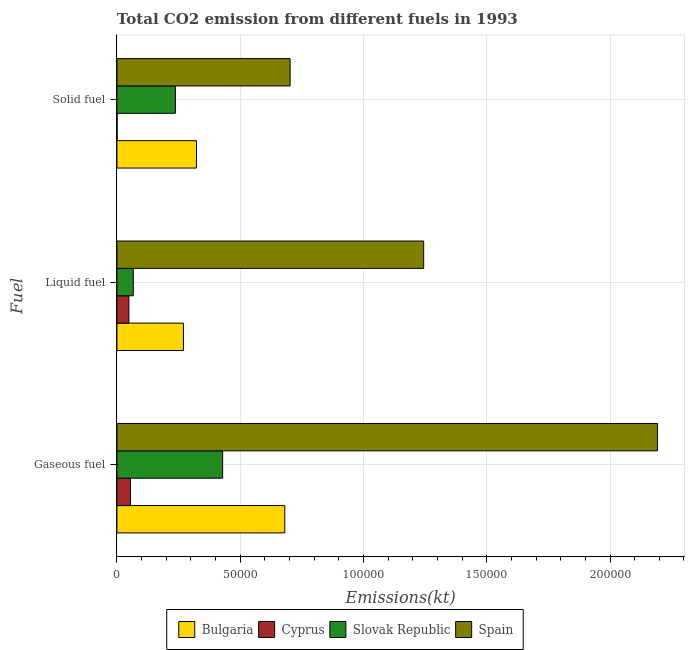Are the number of bars per tick equal to the number of legend labels?
Your response must be concise. Yes. Are the number of bars on each tick of the Y-axis equal?
Your response must be concise. Yes. How many bars are there on the 3rd tick from the top?
Your answer should be very brief. 4. How many bars are there on the 1st tick from the bottom?
Make the answer very short. 4. What is the label of the 3rd group of bars from the top?
Keep it short and to the point. Gaseous fuel. What is the amount of co2 emissions from solid fuel in Cyprus?
Your answer should be very brief. 80.67. Across all countries, what is the maximum amount of co2 emissions from solid fuel?
Ensure brevity in your answer.  7.02e+04. Across all countries, what is the minimum amount of co2 emissions from liquid fuel?
Keep it short and to the point. 4858.77. In which country was the amount of co2 emissions from solid fuel maximum?
Give a very brief answer. Spain. In which country was the amount of co2 emissions from solid fuel minimum?
Provide a short and direct response. Cyprus. What is the total amount of co2 emissions from liquid fuel in the graph?
Offer a terse response. 1.63e+05. What is the difference between the amount of co2 emissions from liquid fuel in Bulgaria and that in Cyprus?
Give a very brief answer. 2.21e+04. What is the difference between the amount of co2 emissions from gaseous fuel in Spain and the amount of co2 emissions from liquid fuel in Cyprus?
Your answer should be very brief. 2.14e+05. What is the average amount of co2 emissions from solid fuel per country?
Provide a succinct answer. 3.16e+04. What is the difference between the amount of co2 emissions from liquid fuel and amount of co2 emissions from gaseous fuel in Cyprus?
Keep it short and to the point. -627.06. In how many countries, is the amount of co2 emissions from gaseous fuel greater than 80000 kt?
Keep it short and to the point. 1. What is the ratio of the amount of co2 emissions from gaseous fuel in Bulgaria to that in Cyprus?
Make the answer very short. 12.41. Is the amount of co2 emissions from liquid fuel in Spain less than that in Slovak Republic?
Offer a terse response. No. Is the difference between the amount of co2 emissions from gaseous fuel in Cyprus and Slovak Republic greater than the difference between the amount of co2 emissions from solid fuel in Cyprus and Slovak Republic?
Offer a very short reply. No. What is the difference between the highest and the second highest amount of co2 emissions from gaseous fuel?
Provide a succinct answer. 1.51e+05. What is the difference between the highest and the lowest amount of co2 emissions from solid fuel?
Your answer should be compact. 7.02e+04. In how many countries, is the amount of co2 emissions from gaseous fuel greater than the average amount of co2 emissions from gaseous fuel taken over all countries?
Keep it short and to the point. 1. What does the 3rd bar from the top in Solid fuel represents?
Offer a very short reply. Cyprus. What does the 4th bar from the bottom in Solid fuel represents?
Your response must be concise. Spain. Is it the case that in every country, the sum of the amount of co2 emissions from gaseous fuel and amount of co2 emissions from liquid fuel is greater than the amount of co2 emissions from solid fuel?
Keep it short and to the point. Yes. How many countries are there in the graph?
Provide a short and direct response. 4. Are the values on the major ticks of X-axis written in scientific E-notation?
Give a very brief answer. No. Does the graph contain grids?
Offer a very short reply. Yes. What is the title of the graph?
Provide a succinct answer. Total CO2 emission from different fuels in 1993. What is the label or title of the X-axis?
Keep it short and to the point. Emissions(kt). What is the label or title of the Y-axis?
Your answer should be very brief. Fuel. What is the Emissions(kt) in Bulgaria in Gaseous fuel?
Your answer should be very brief. 6.81e+04. What is the Emissions(kt) in Cyprus in Gaseous fuel?
Offer a terse response. 5485.83. What is the Emissions(kt) of Slovak Republic in Gaseous fuel?
Provide a short and direct response. 4.29e+04. What is the Emissions(kt) of Spain in Gaseous fuel?
Offer a terse response. 2.19e+05. What is the Emissions(kt) in Bulgaria in Liquid fuel?
Provide a succinct answer. 2.70e+04. What is the Emissions(kt) of Cyprus in Liquid fuel?
Your response must be concise. 4858.77. What is the Emissions(kt) in Slovak Republic in Liquid fuel?
Your answer should be compact. 6637.27. What is the Emissions(kt) in Spain in Liquid fuel?
Give a very brief answer. 1.24e+05. What is the Emissions(kt) of Bulgaria in Solid fuel?
Ensure brevity in your answer.  3.23e+04. What is the Emissions(kt) in Cyprus in Solid fuel?
Make the answer very short. 80.67. What is the Emissions(kt) of Slovak Republic in Solid fuel?
Your response must be concise. 2.37e+04. What is the Emissions(kt) in Spain in Solid fuel?
Provide a succinct answer. 7.02e+04. Across all Fuel, what is the maximum Emissions(kt) in Bulgaria?
Make the answer very short. 6.81e+04. Across all Fuel, what is the maximum Emissions(kt) in Cyprus?
Offer a very short reply. 5485.83. Across all Fuel, what is the maximum Emissions(kt) of Slovak Republic?
Provide a succinct answer. 4.29e+04. Across all Fuel, what is the maximum Emissions(kt) in Spain?
Offer a very short reply. 2.19e+05. Across all Fuel, what is the minimum Emissions(kt) in Bulgaria?
Keep it short and to the point. 2.70e+04. Across all Fuel, what is the minimum Emissions(kt) of Cyprus?
Make the answer very short. 80.67. Across all Fuel, what is the minimum Emissions(kt) of Slovak Republic?
Give a very brief answer. 6637.27. Across all Fuel, what is the minimum Emissions(kt) in Spain?
Your answer should be compact. 7.02e+04. What is the total Emissions(kt) in Bulgaria in the graph?
Make the answer very short. 1.27e+05. What is the total Emissions(kt) in Cyprus in the graph?
Your answer should be very brief. 1.04e+04. What is the total Emissions(kt) in Slovak Republic in the graph?
Give a very brief answer. 7.32e+04. What is the total Emissions(kt) in Spain in the graph?
Your answer should be very brief. 4.14e+05. What is the difference between the Emissions(kt) of Bulgaria in Gaseous fuel and that in Liquid fuel?
Offer a very short reply. 4.11e+04. What is the difference between the Emissions(kt) in Cyprus in Gaseous fuel and that in Liquid fuel?
Your answer should be very brief. 627.06. What is the difference between the Emissions(kt) of Slovak Republic in Gaseous fuel and that in Liquid fuel?
Make the answer very short. 3.62e+04. What is the difference between the Emissions(kt) of Spain in Gaseous fuel and that in Liquid fuel?
Ensure brevity in your answer.  9.48e+04. What is the difference between the Emissions(kt) in Bulgaria in Gaseous fuel and that in Solid fuel?
Ensure brevity in your answer.  3.58e+04. What is the difference between the Emissions(kt) of Cyprus in Gaseous fuel and that in Solid fuel?
Your answer should be compact. 5405.16. What is the difference between the Emissions(kt) in Slovak Republic in Gaseous fuel and that in Solid fuel?
Give a very brief answer. 1.92e+04. What is the difference between the Emissions(kt) in Spain in Gaseous fuel and that in Solid fuel?
Offer a terse response. 1.49e+05. What is the difference between the Emissions(kt) of Bulgaria in Liquid fuel and that in Solid fuel?
Your answer should be very brief. -5291.48. What is the difference between the Emissions(kt) of Cyprus in Liquid fuel and that in Solid fuel?
Provide a succinct answer. 4778.1. What is the difference between the Emissions(kt) in Slovak Republic in Liquid fuel and that in Solid fuel?
Your answer should be compact. -1.71e+04. What is the difference between the Emissions(kt) of Spain in Liquid fuel and that in Solid fuel?
Your answer should be compact. 5.42e+04. What is the difference between the Emissions(kt) of Bulgaria in Gaseous fuel and the Emissions(kt) of Cyprus in Liquid fuel?
Provide a short and direct response. 6.32e+04. What is the difference between the Emissions(kt) of Bulgaria in Gaseous fuel and the Emissions(kt) of Slovak Republic in Liquid fuel?
Make the answer very short. 6.14e+04. What is the difference between the Emissions(kt) in Bulgaria in Gaseous fuel and the Emissions(kt) in Spain in Liquid fuel?
Keep it short and to the point. -5.63e+04. What is the difference between the Emissions(kt) in Cyprus in Gaseous fuel and the Emissions(kt) in Slovak Republic in Liquid fuel?
Your answer should be compact. -1151.44. What is the difference between the Emissions(kt) in Cyprus in Gaseous fuel and the Emissions(kt) in Spain in Liquid fuel?
Provide a short and direct response. -1.19e+05. What is the difference between the Emissions(kt) of Slovak Republic in Gaseous fuel and the Emissions(kt) of Spain in Liquid fuel?
Keep it short and to the point. -8.15e+04. What is the difference between the Emissions(kt) in Bulgaria in Gaseous fuel and the Emissions(kt) in Cyprus in Solid fuel?
Give a very brief answer. 6.80e+04. What is the difference between the Emissions(kt) in Bulgaria in Gaseous fuel and the Emissions(kt) in Slovak Republic in Solid fuel?
Offer a very short reply. 4.44e+04. What is the difference between the Emissions(kt) of Bulgaria in Gaseous fuel and the Emissions(kt) of Spain in Solid fuel?
Your answer should be very brief. -2163.53. What is the difference between the Emissions(kt) of Cyprus in Gaseous fuel and the Emissions(kt) of Slovak Republic in Solid fuel?
Your answer should be very brief. -1.82e+04. What is the difference between the Emissions(kt) of Cyprus in Gaseous fuel and the Emissions(kt) of Spain in Solid fuel?
Offer a terse response. -6.48e+04. What is the difference between the Emissions(kt) of Slovak Republic in Gaseous fuel and the Emissions(kt) of Spain in Solid fuel?
Your answer should be very brief. -2.74e+04. What is the difference between the Emissions(kt) in Bulgaria in Liquid fuel and the Emissions(kt) in Cyprus in Solid fuel?
Your answer should be compact. 2.69e+04. What is the difference between the Emissions(kt) of Bulgaria in Liquid fuel and the Emissions(kt) of Slovak Republic in Solid fuel?
Provide a succinct answer. 3270.96. What is the difference between the Emissions(kt) in Bulgaria in Liquid fuel and the Emissions(kt) in Spain in Solid fuel?
Keep it short and to the point. -4.33e+04. What is the difference between the Emissions(kt) of Cyprus in Liquid fuel and the Emissions(kt) of Slovak Republic in Solid fuel?
Offer a very short reply. -1.88e+04. What is the difference between the Emissions(kt) of Cyprus in Liquid fuel and the Emissions(kt) of Spain in Solid fuel?
Your response must be concise. -6.54e+04. What is the difference between the Emissions(kt) in Slovak Republic in Liquid fuel and the Emissions(kt) in Spain in Solid fuel?
Keep it short and to the point. -6.36e+04. What is the average Emissions(kt) in Bulgaria per Fuel?
Give a very brief answer. 4.24e+04. What is the average Emissions(kt) of Cyprus per Fuel?
Offer a very short reply. 3475.09. What is the average Emissions(kt) in Slovak Republic per Fuel?
Keep it short and to the point. 2.44e+04. What is the average Emissions(kt) in Spain per Fuel?
Offer a terse response. 1.38e+05. What is the difference between the Emissions(kt) of Bulgaria and Emissions(kt) of Cyprus in Gaseous fuel?
Offer a terse response. 6.26e+04. What is the difference between the Emissions(kt) in Bulgaria and Emissions(kt) in Slovak Republic in Gaseous fuel?
Keep it short and to the point. 2.52e+04. What is the difference between the Emissions(kt) of Bulgaria and Emissions(kt) of Spain in Gaseous fuel?
Offer a very short reply. -1.51e+05. What is the difference between the Emissions(kt) in Cyprus and Emissions(kt) in Slovak Republic in Gaseous fuel?
Your answer should be very brief. -3.74e+04. What is the difference between the Emissions(kt) of Cyprus and Emissions(kt) of Spain in Gaseous fuel?
Your answer should be very brief. -2.14e+05. What is the difference between the Emissions(kt) in Slovak Republic and Emissions(kt) in Spain in Gaseous fuel?
Make the answer very short. -1.76e+05. What is the difference between the Emissions(kt) in Bulgaria and Emissions(kt) in Cyprus in Liquid fuel?
Make the answer very short. 2.21e+04. What is the difference between the Emissions(kt) of Bulgaria and Emissions(kt) of Slovak Republic in Liquid fuel?
Keep it short and to the point. 2.03e+04. What is the difference between the Emissions(kt) of Bulgaria and Emissions(kt) of Spain in Liquid fuel?
Give a very brief answer. -9.74e+04. What is the difference between the Emissions(kt) of Cyprus and Emissions(kt) of Slovak Republic in Liquid fuel?
Provide a short and direct response. -1778.49. What is the difference between the Emissions(kt) of Cyprus and Emissions(kt) of Spain in Liquid fuel?
Your answer should be compact. -1.20e+05. What is the difference between the Emissions(kt) in Slovak Republic and Emissions(kt) in Spain in Liquid fuel?
Provide a short and direct response. -1.18e+05. What is the difference between the Emissions(kt) in Bulgaria and Emissions(kt) in Cyprus in Solid fuel?
Offer a very short reply. 3.22e+04. What is the difference between the Emissions(kt) in Bulgaria and Emissions(kt) in Slovak Republic in Solid fuel?
Ensure brevity in your answer.  8562.44. What is the difference between the Emissions(kt) of Bulgaria and Emissions(kt) of Spain in Solid fuel?
Your answer should be compact. -3.80e+04. What is the difference between the Emissions(kt) in Cyprus and Emissions(kt) in Slovak Republic in Solid fuel?
Keep it short and to the point. -2.36e+04. What is the difference between the Emissions(kt) in Cyprus and Emissions(kt) in Spain in Solid fuel?
Ensure brevity in your answer.  -7.02e+04. What is the difference between the Emissions(kt) in Slovak Republic and Emissions(kt) in Spain in Solid fuel?
Your answer should be very brief. -4.65e+04. What is the ratio of the Emissions(kt) of Bulgaria in Gaseous fuel to that in Liquid fuel?
Ensure brevity in your answer.  2.52. What is the ratio of the Emissions(kt) of Cyprus in Gaseous fuel to that in Liquid fuel?
Your answer should be compact. 1.13. What is the ratio of the Emissions(kt) of Slovak Republic in Gaseous fuel to that in Liquid fuel?
Offer a terse response. 6.46. What is the ratio of the Emissions(kt) of Spain in Gaseous fuel to that in Liquid fuel?
Ensure brevity in your answer.  1.76. What is the ratio of the Emissions(kt) in Bulgaria in Gaseous fuel to that in Solid fuel?
Make the answer very short. 2.11. What is the ratio of the Emissions(kt) of Cyprus in Gaseous fuel to that in Solid fuel?
Ensure brevity in your answer.  68. What is the ratio of the Emissions(kt) of Slovak Republic in Gaseous fuel to that in Solid fuel?
Offer a terse response. 1.81. What is the ratio of the Emissions(kt) in Spain in Gaseous fuel to that in Solid fuel?
Provide a short and direct response. 3.12. What is the ratio of the Emissions(kt) in Bulgaria in Liquid fuel to that in Solid fuel?
Keep it short and to the point. 0.84. What is the ratio of the Emissions(kt) in Cyprus in Liquid fuel to that in Solid fuel?
Provide a succinct answer. 60.23. What is the ratio of the Emissions(kt) in Slovak Republic in Liquid fuel to that in Solid fuel?
Your answer should be compact. 0.28. What is the ratio of the Emissions(kt) of Spain in Liquid fuel to that in Solid fuel?
Your answer should be compact. 1.77. What is the difference between the highest and the second highest Emissions(kt) in Bulgaria?
Keep it short and to the point. 3.58e+04. What is the difference between the highest and the second highest Emissions(kt) of Cyprus?
Make the answer very short. 627.06. What is the difference between the highest and the second highest Emissions(kt) in Slovak Republic?
Make the answer very short. 1.92e+04. What is the difference between the highest and the second highest Emissions(kt) of Spain?
Provide a succinct answer. 9.48e+04. What is the difference between the highest and the lowest Emissions(kt) of Bulgaria?
Provide a short and direct response. 4.11e+04. What is the difference between the highest and the lowest Emissions(kt) of Cyprus?
Offer a very short reply. 5405.16. What is the difference between the highest and the lowest Emissions(kt) in Slovak Republic?
Give a very brief answer. 3.62e+04. What is the difference between the highest and the lowest Emissions(kt) in Spain?
Your response must be concise. 1.49e+05. 